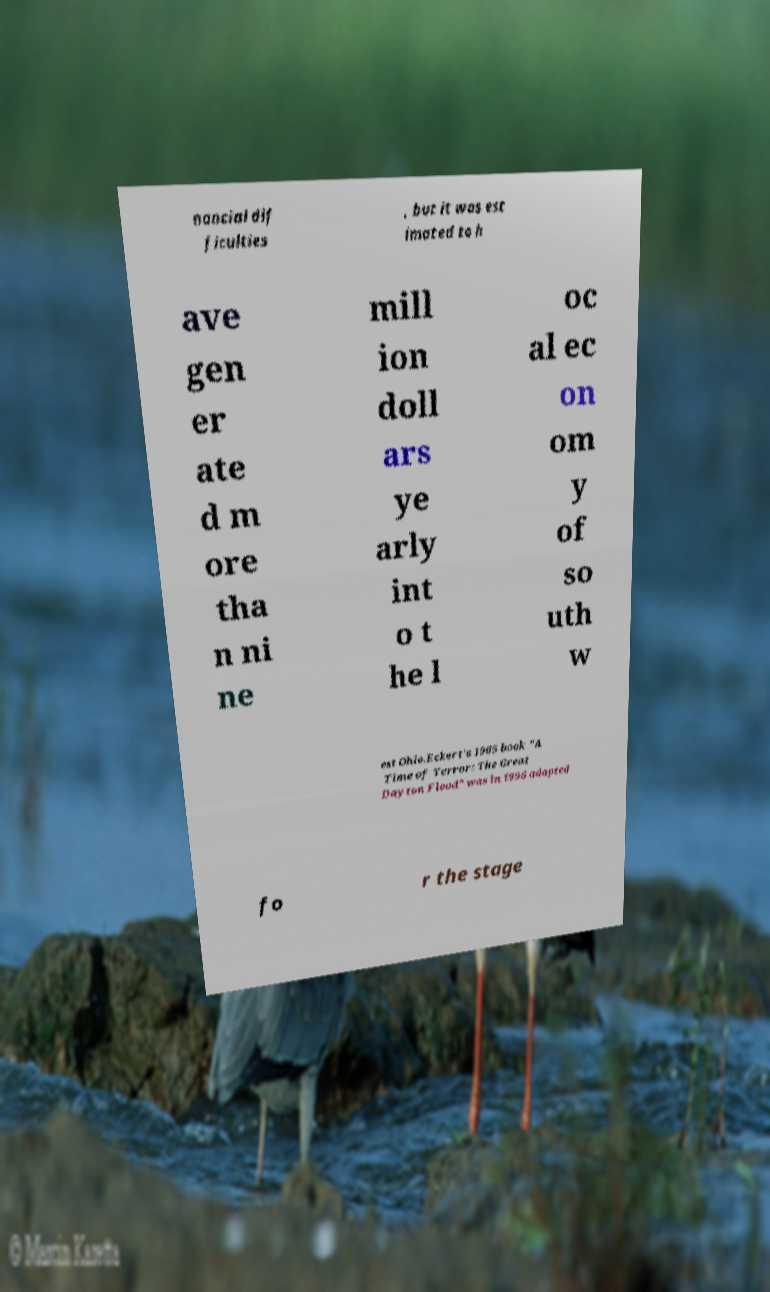For documentation purposes, I need the text within this image transcribed. Could you provide that? nancial dif ficulties , but it was est imated to h ave gen er ate d m ore tha n ni ne mill ion doll ars ye arly int o t he l oc al ec on om y of so uth w est Ohio.Eckert's 1965 book "A Time of Terror: The Great Dayton Flood" was in 1996 adapted fo r the stage 